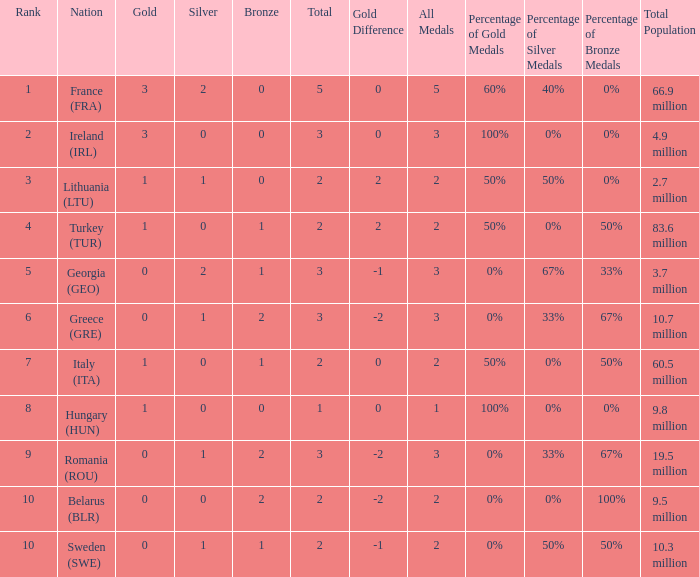What's the total of rank 8 when Silver medals are 0 and gold is more than 1? 0.0. Help me parse the entirety of this table. {'header': ['Rank', 'Nation', 'Gold', 'Silver', 'Bronze', 'Total', 'Gold Difference', 'All Medals', 'Percentage of Gold Medals', 'Percentage of Silver Medals', 'Percentage of Bronze Medals', 'Total Population'], 'rows': [['1', 'France (FRA)', '3', '2', '0', '5', '0', '5', '60%', '40%', '0%', '66.9 million'], ['2', 'Ireland (IRL)', '3', '0', '0', '3', '0', '3', '100%', '0%', '0%', '4.9 million'], ['3', 'Lithuania (LTU)', '1', '1', '0', '2', '2', '2', '50%', '50%', '0%', '2.7 million'], ['4', 'Turkey (TUR)', '1', '0', '1', '2', '2', '2', '50%', '0%', '50%', '83.6 million'], ['5', 'Georgia (GEO)', '0', '2', '1', '3', '-1', '3', '0%', '67%', '33%', '3.7 million'], ['6', 'Greece (GRE)', '0', '1', '2', '3', '-2', '3', '0%', '33%', '67%', '10.7 million'], ['7', 'Italy (ITA)', '1', '0', '1', '2', '0', '2', '50%', '0%', '50%', '60.5 million'], ['8', 'Hungary (HUN)', '1', '0', '0', '1', '0', '1', '100%', '0%', '0%', '9.8 million'], ['9', 'Romania (ROU)', '0', '1', '2', '3', '-2', '3', '0%', '33%', '67%', '19.5 million'], ['10', 'Belarus (BLR)', '0', '0', '2', '2', '-2', '2', '0%', '0%', '100%', '9.5 million'], ['10', 'Sweden (SWE)', '0', '1', '1', '2', '-1', '2', '0%', '50%', '50%', '10.3 million']]} 